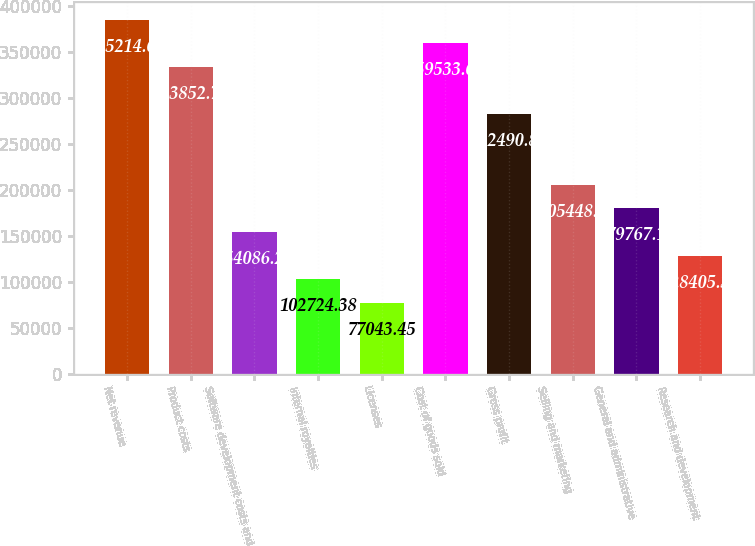<chart> <loc_0><loc_0><loc_500><loc_500><bar_chart><fcel>Net revenue<fcel>Product costs<fcel>Software development costs and<fcel>Internal royalties<fcel>Licenses<fcel>Cost of goods sold<fcel>Gross profit<fcel>Selling and marketing<fcel>General and administrative<fcel>Research and development<nl><fcel>385215<fcel>333853<fcel>154086<fcel>102724<fcel>77043.4<fcel>359534<fcel>282491<fcel>205448<fcel>179767<fcel>128405<nl></chart> 